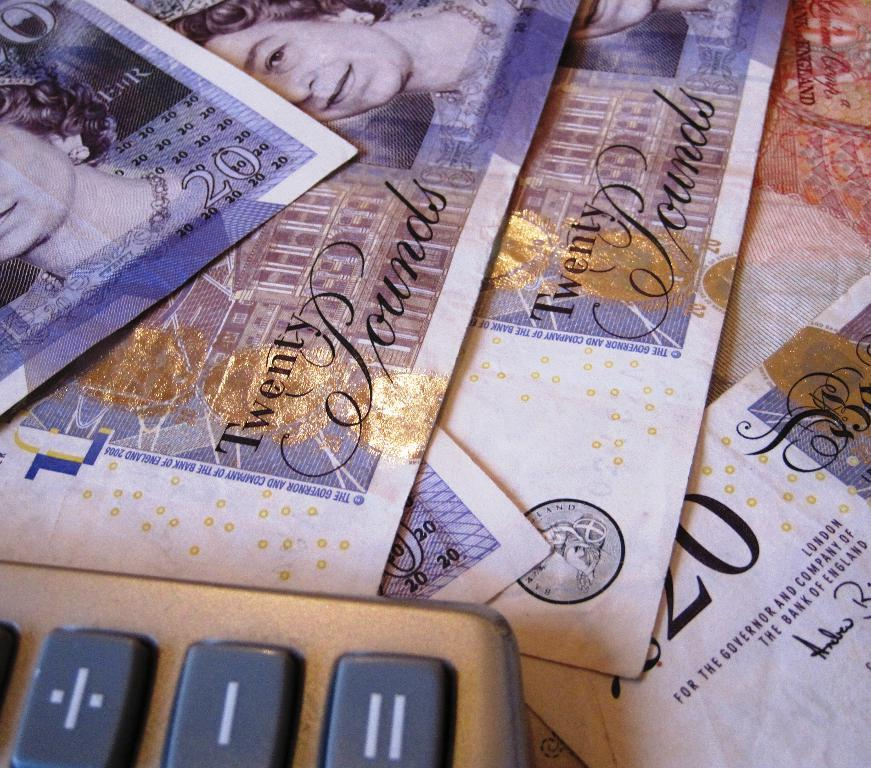What type of objects can be seen in the image? There are currency notes in the image. Can you describe any other objects present in the image? Yes, there is a calculator at the left bottom of the image. What type of yam is being used to count the currency notes in the image? There is no yam present in the image; it only features currency notes and a calculator. What nation is represented by the currency notes in the image? The facts provided do not specify the nation represented by the currency notes, so it cannot be determined from the image. 